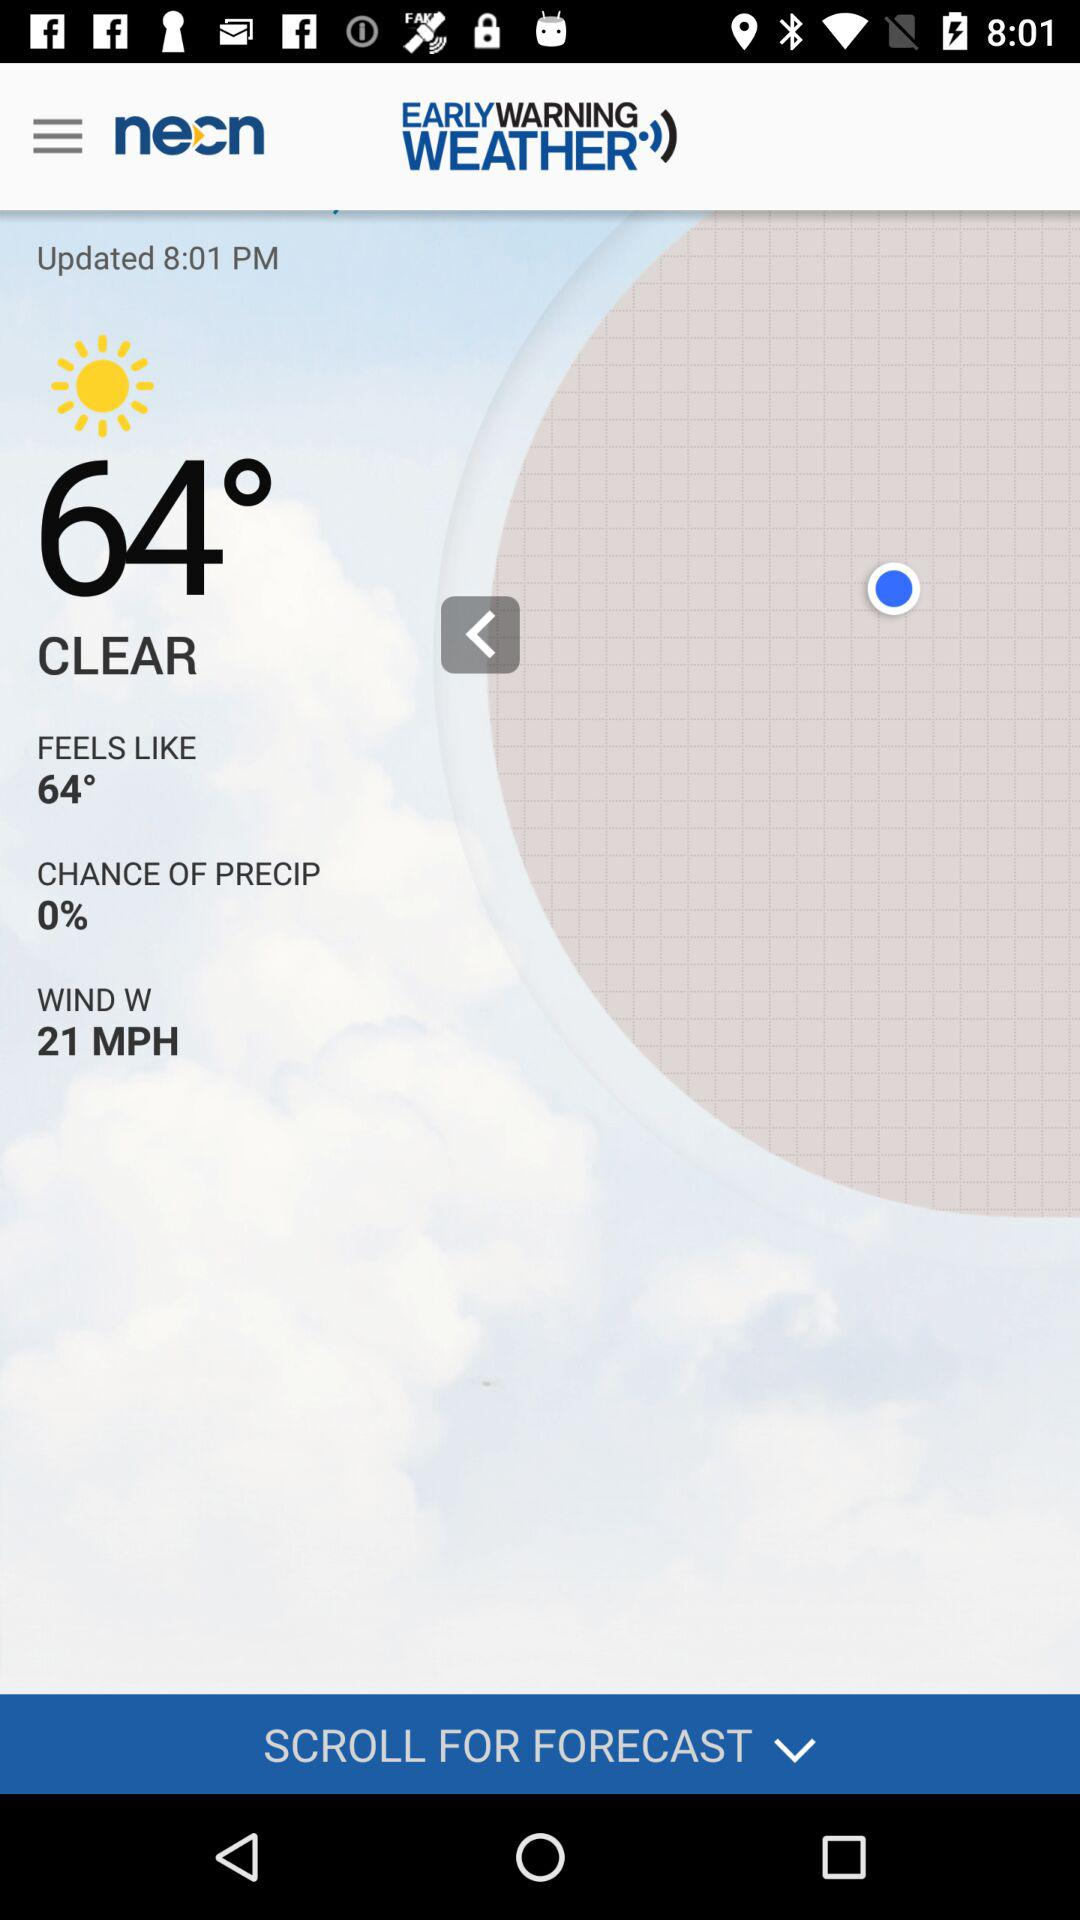What is the temperature? The temperature is 64°. 